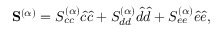<formula> <loc_0><loc_0><loc_500><loc_500>S ^ { ( \alpha ) } = S _ { c c } ^ { ( \alpha ) } \hat { c } \hat { c } + S _ { d d } ^ { ( \alpha ) } \hat { d } \hat { d } + S _ { e e } ^ { ( \alpha ) } \hat { e } \hat { e } ,</formula> 